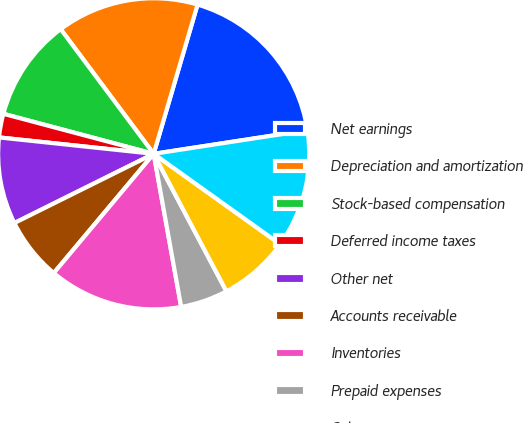Convert chart. <chart><loc_0><loc_0><loc_500><loc_500><pie_chart><fcel>Net earnings<fcel>Depreciation and amortization<fcel>Stock-based compensation<fcel>Deferred income taxes<fcel>Other net<fcel>Accounts receivable<fcel>Inventories<fcel>Prepaid expenses<fcel>Other assets<fcel>Accounts payable<nl><fcel>18.03%<fcel>14.75%<fcel>10.66%<fcel>2.46%<fcel>9.02%<fcel>6.56%<fcel>13.93%<fcel>4.92%<fcel>7.38%<fcel>12.3%<nl></chart> 